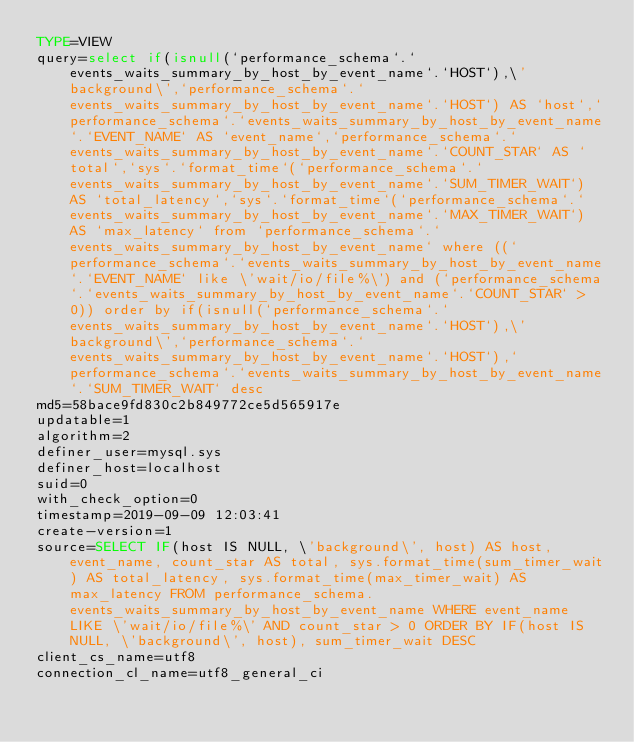Convert code to text. <code><loc_0><loc_0><loc_500><loc_500><_VisualBasic_>TYPE=VIEW
query=select if(isnull(`performance_schema`.`events_waits_summary_by_host_by_event_name`.`HOST`),\'background\',`performance_schema`.`events_waits_summary_by_host_by_event_name`.`HOST`) AS `host`,`performance_schema`.`events_waits_summary_by_host_by_event_name`.`EVENT_NAME` AS `event_name`,`performance_schema`.`events_waits_summary_by_host_by_event_name`.`COUNT_STAR` AS `total`,`sys`.`format_time`(`performance_schema`.`events_waits_summary_by_host_by_event_name`.`SUM_TIMER_WAIT`) AS `total_latency`,`sys`.`format_time`(`performance_schema`.`events_waits_summary_by_host_by_event_name`.`MAX_TIMER_WAIT`) AS `max_latency` from `performance_schema`.`events_waits_summary_by_host_by_event_name` where ((`performance_schema`.`events_waits_summary_by_host_by_event_name`.`EVENT_NAME` like \'wait/io/file%\') and (`performance_schema`.`events_waits_summary_by_host_by_event_name`.`COUNT_STAR` > 0)) order by if(isnull(`performance_schema`.`events_waits_summary_by_host_by_event_name`.`HOST`),\'background\',`performance_schema`.`events_waits_summary_by_host_by_event_name`.`HOST`),`performance_schema`.`events_waits_summary_by_host_by_event_name`.`SUM_TIMER_WAIT` desc
md5=58bace9fd830c2b849772ce5d565917e
updatable=1
algorithm=2
definer_user=mysql.sys
definer_host=localhost
suid=0
with_check_option=0
timestamp=2019-09-09 12:03:41
create-version=1
source=SELECT IF(host IS NULL, \'background\', host) AS host, event_name, count_star AS total, sys.format_time(sum_timer_wait) AS total_latency, sys.format_time(max_timer_wait) AS max_latency FROM performance_schema.events_waits_summary_by_host_by_event_name WHERE event_name LIKE \'wait/io/file%\' AND count_star > 0 ORDER BY IF(host IS NULL, \'background\', host), sum_timer_wait DESC
client_cs_name=utf8
connection_cl_name=utf8_general_ci</code> 